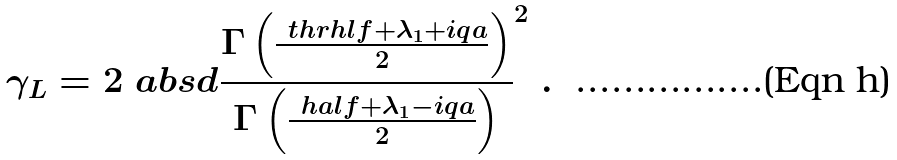<formula> <loc_0><loc_0><loc_500><loc_500>\gamma _ { L } = 2 \ a b s d { \frac { \Gamma \left ( \frac { \ t h r h l f + \lambda _ { 1 } + i q a } { 2 } \right ) } { \Gamma \left ( \frac { \ h a l f + \lambda _ { 1 } - i q a } { 2 } \right ) } } ^ { 2 } \ .</formula> 